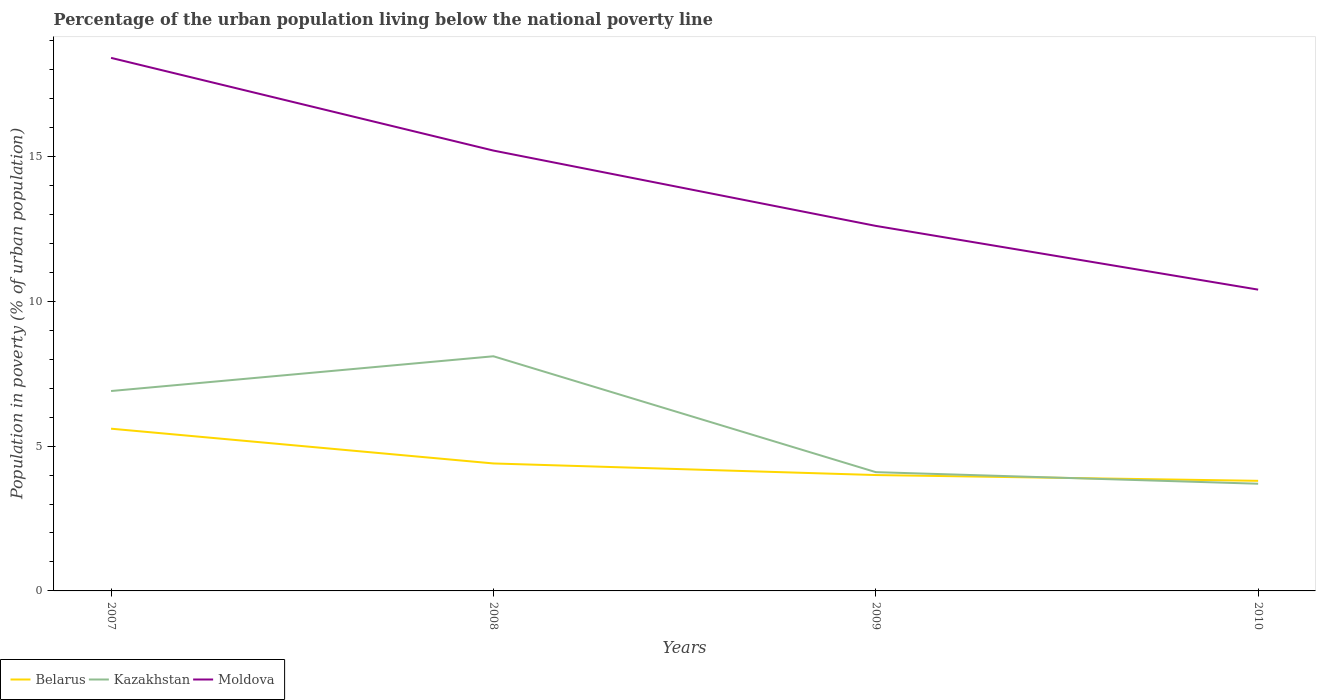Is the number of lines equal to the number of legend labels?
Offer a very short reply. Yes. In which year was the percentage of the urban population living below the national poverty line in Belarus maximum?
Provide a short and direct response. 2010. What is the total percentage of the urban population living below the national poverty line in Moldova in the graph?
Your answer should be very brief. 4.8. What is the difference between the highest and the second highest percentage of the urban population living below the national poverty line in Moldova?
Keep it short and to the point. 8. What is the difference between the highest and the lowest percentage of the urban population living below the national poverty line in Kazakhstan?
Your response must be concise. 2. Are the values on the major ticks of Y-axis written in scientific E-notation?
Give a very brief answer. No. Does the graph contain grids?
Keep it short and to the point. No. Where does the legend appear in the graph?
Give a very brief answer. Bottom left. How many legend labels are there?
Give a very brief answer. 3. How are the legend labels stacked?
Make the answer very short. Horizontal. What is the title of the graph?
Keep it short and to the point. Percentage of the urban population living below the national poverty line. What is the label or title of the X-axis?
Your response must be concise. Years. What is the label or title of the Y-axis?
Keep it short and to the point. Population in poverty (% of urban population). What is the Population in poverty (% of urban population) of Belarus in 2007?
Give a very brief answer. 5.6. What is the Population in poverty (% of urban population) in Kazakhstan in 2007?
Your answer should be compact. 6.9. What is the Population in poverty (% of urban population) in Moldova in 2007?
Offer a terse response. 18.4. What is the Population in poverty (% of urban population) of Belarus in 2008?
Give a very brief answer. 4.4. What is the Population in poverty (% of urban population) of Kazakhstan in 2008?
Provide a short and direct response. 8.1. What is the Population in poverty (% of urban population) in Moldova in 2008?
Your response must be concise. 15.2. What is the Population in poverty (% of urban population) of Belarus in 2009?
Offer a terse response. 4. What is the Population in poverty (% of urban population) of Kazakhstan in 2009?
Provide a short and direct response. 4.1. What is the Population in poverty (% of urban population) of Moldova in 2009?
Provide a succinct answer. 12.6. What is the Population in poverty (% of urban population) of Belarus in 2010?
Keep it short and to the point. 3.8. What is the Population in poverty (% of urban population) of Kazakhstan in 2010?
Your response must be concise. 3.7. What is the Population in poverty (% of urban population) of Moldova in 2010?
Provide a short and direct response. 10.4. Across all years, what is the maximum Population in poverty (% of urban population) in Kazakhstan?
Provide a short and direct response. 8.1. Across all years, what is the minimum Population in poverty (% of urban population) of Moldova?
Keep it short and to the point. 10.4. What is the total Population in poverty (% of urban population) of Kazakhstan in the graph?
Your answer should be very brief. 22.8. What is the total Population in poverty (% of urban population) of Moldova in the graph?
Keep it short and to the point. 56.6. What is the difference between the Population in poverty (% of urban population) in Moldova in 2007 and that in 2008?
Your answer should be very brief. 3.2. What is the difference between the Population in poverty (% of urban population) of Kazakhstan in 2007 and that in 2009?
Your answer should be compact. 2.8. What is the difference between the Population in poverty (% of urban population) in Moldova in 2007 and that in 2009?
Keep it short and to the point. 5.8. What is the difference between the Population in poverty (% of urban population) in Kazakhstan in 2007 and that in 2010?
Your answer should be compact. 3.2. What is the difference between the Population in poverty (% of urban population) of Belarus in 2008 and that in 2009?
Give a very brief answer. 0.4. What is the difference between the Population in poverty (% of urban population) of Kazakhstan in 2008 and that in 2009?
Keep it short and to the point. 4. What is the difference between the Population in poverty (% of urban population) of Moldova in 2008 and that in 2009?
Offer a terse response. 2.6. What is the difference between the Population in poverty (% of urban population) of Belarus in 2008 and that in 2010?
Offer a very short reply. 0.6. What is the difference between the Population in poverty (% of urban population) in Kazakhstan in 2008 and that in 2010?
Ensure brevity in your answer.  4.4. What is the difference between the Population in poverty (% of urban population) in Kazakhstan in 2009 and that in 2010?
Offer a very short reply. 0.4. What is the difference between the Population in poverty (% of urban population) in Kazakhstan in 2007 and the Population in poverty (% of urban population) in Moldova in 2008?
Your answer should be very brief. -8.3. What is the difference between the Population in poverty (% of urban population) of Belarus in 2007 and the Population in poverty (% of urban population) of Moldova in 2009?
Offer a very short reply. -7. What is the difference between the Population in poverty (% of urban population) of Belarus in 2007 and the Population in poverty (% of urban population) of Kazakhstan in 2010?
Ensure brevity in your answer.  1.9. What is the difference between the Population in poverty (% of urban population) in Belarus in 2007 and the Population in poverty (% of urban population) in Moldova in 2010?
Provide a succinct answer. -4.8. What is the difference between the Population in poverty (% of urban population) in Kazakhstan in 2008 and the Population in poverty (% of urban population) in Moldova in 2009?
Offer a very short reply. -4.5. What is the difference between the Population in poverty (% of urban population) of Belarus in 2008 and the Population in poverty (% of urban population) of Kazakhstan in 2010?
Your response must be concise. 0.7. What is the difference between the Population in poverty (% of urban population) of Belarus in 2009 and the Population in poverty (% of urban population) of Moldova in 2010?
Offer a terse response. -6.4. What is the average Population in poverty (% of urban population) of Belarus per year?
Provide a succinct answer. 4.45. What is the average Population in poverty (% of urban population) of Moldova per year?
Your answer should be very brief. 14.15. In the year 2007, what is the difference between the Population in poverty (% of urban population) of Belarus and Population in poverty (% of urban population) of Moldova?
Make the answer very short. -12.8. In the year 2007, what is the difference between the Population in poverty (% of urban population) of Kazakhstan and Population in poverty (% of urban population) of Moldova?
Give a very brief answer. -11.5. In the year 2008, what is the difference between the Population in poverty (% of urban population) in Belarus and Population in poverty (% of urban population) in Kazakhstan?
Your answer should be compact. -3.7. In the year 2008, what is the difference between the Population in poverty (% of urban population) of Belarus and Population in poverty (% of urban population) of Moldova?
Offer a very short reply. -10.8. In the year 2008, what is the difference between the Population in poverty (% of urban population) in Kazakhstan and Population in poverty (% of urban population) in Moldova?
Make the answer very short. -7.1. In the year 2009, what is the difference between the Population in poverty (% of urban population) of Belarus and Population in poverty (% of urban population) of Kazakhstan?
Your response must be concise. -0.1. In the year 2009, what is the difference between the Population in poverty (% of urban population) of Kazakhstan and Population in poverty (% of urban population) of Moldova?
Offer a very short reply. -8.5. In the year 2010, what is the difference between the Population in poverty (% of urban population) of Belarus and Population in poverty (% of urban population) of Kazakhstan?
Provide a short and direct response. 0.1. In the year 2010, what is the difference between the Population in poverty (% of urban population) in Kazakhstan and Population in poverty (% of urban population) in Moldova?
Give a very brief answer. -6.7. What is the ratio of the Population in poverty (% of urban population) in Belarus in 2007 to that in 2008?
Give a very brief answer. 1.27. What is the ratio of the Population in poverty (% of urban population) of Kazakhstan in 2007 to that in 2008?
Make the answer very short. 0.85. What is the ratio of the Population in poverty (% of urban population) in Moldova in 2007 to that in 2008?
Provide a short and direct response. 1.21. What is the ratio of the Population in poverty (% of urban population) in Kazakhstan in 2007 to that in 2009?
Give a very brief answer. 1.68. What is the ratio of the Population in poverty (% of urban population) of Moldova in 2007 to that in 2009?
Keep it short and to the point. 1.46. What is the ratio of the Population in poverty (% of urban population) in Belarus in 2007 to that in 2010?
Offer a very short reply. 1.47. What is the ratio of the Population in poverty (% of urban population) of Kazakhstan in 2007 to that in 2010?
Ensure brevity in your answer.  1.86. What is the ratio of the Population in poverty (% of urban population) in Moldova in 2007 to that in 2010?
Offer a terse response. 1.77. What is the ratio of the Population in poverty (% of urban population) in Kazakhstan in 2008 to that in 2009?
Provide a short and direct response. 1.98. What is the ratio of the Population in poverty (% of urban population) in Moldova in 2008 to that in 2009?
Your answer should be compact. 1.21. What is the ratio of the Population in poverty (% of urban population) of Belarus in 2008 to that in 2010?
Give a very brief answer. 1.16. What is the ratio of the Population in poverty (% of urban population) in Kazakhstan in 2008 to that in 2010?
Provide a succinct answer. 2.19. What is the ratio of the Population in poverty (% of urban population) of Moldova in 2008 to that in 2010?
Keep it short and to the point. 1.46. What is the ratio of the Population in poverty (% of urban population) in Belarus in 2009 to that in 2010?
Your response must be concise. 1.05. What is the ratio of the Population in poverty (% of urban population) in Kazakhstan in 2009 to that in 2010?
Give a very brief answer. 1.11. What is the ratio of the Population in poverty (% of urban population) in Moldova in 2009 to that in 2010?
Provide a short and direct response. 1.21. What is the difference between the highest and the second highest Population in poverty (% of urban population) in Belarus?
Keep it short and to the point. 1.2. What is the difference between the highest and the second highest Population in poverty (% of urban population) in Kazakhstan?
Offer a terse response. 1.2. 